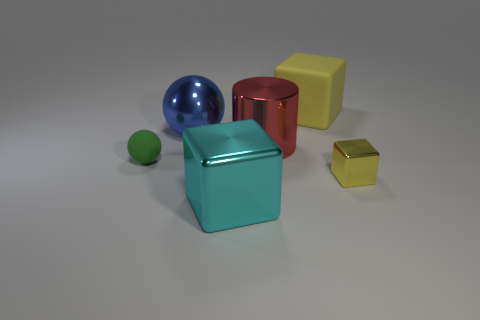Subtract all yellow cubes. How many cubes are left? 1 Add 3 small gray rubber cylinders. How many objects exist? 9 Subtract all balls. How many objects are left? 4 Subtract 0 red spheres. How many objects are left? 6 Subtract all small gray cylinders. Subtract all cyan shiny things. How many objects are left? 5 Add 1 small yellow metal things. How many small yellow metal things are left? 2 Add 4 cyan metallic objects. How many cyan metallic objects exist? 5 